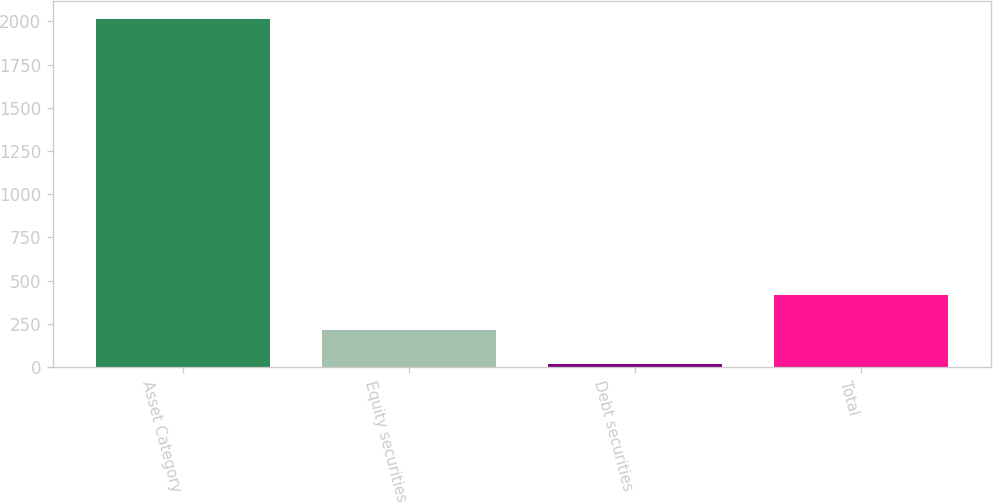<chart> <loc_0><loc_0><loc_500><loc_500><bar_chart><fcel>Asset Category<fcel>Equity securities<fcel>Debt securities<fcel>Total<nl><fcel>2016<fcel>214.58<fcel>14.42<fcel>414.74<nl></chart> 